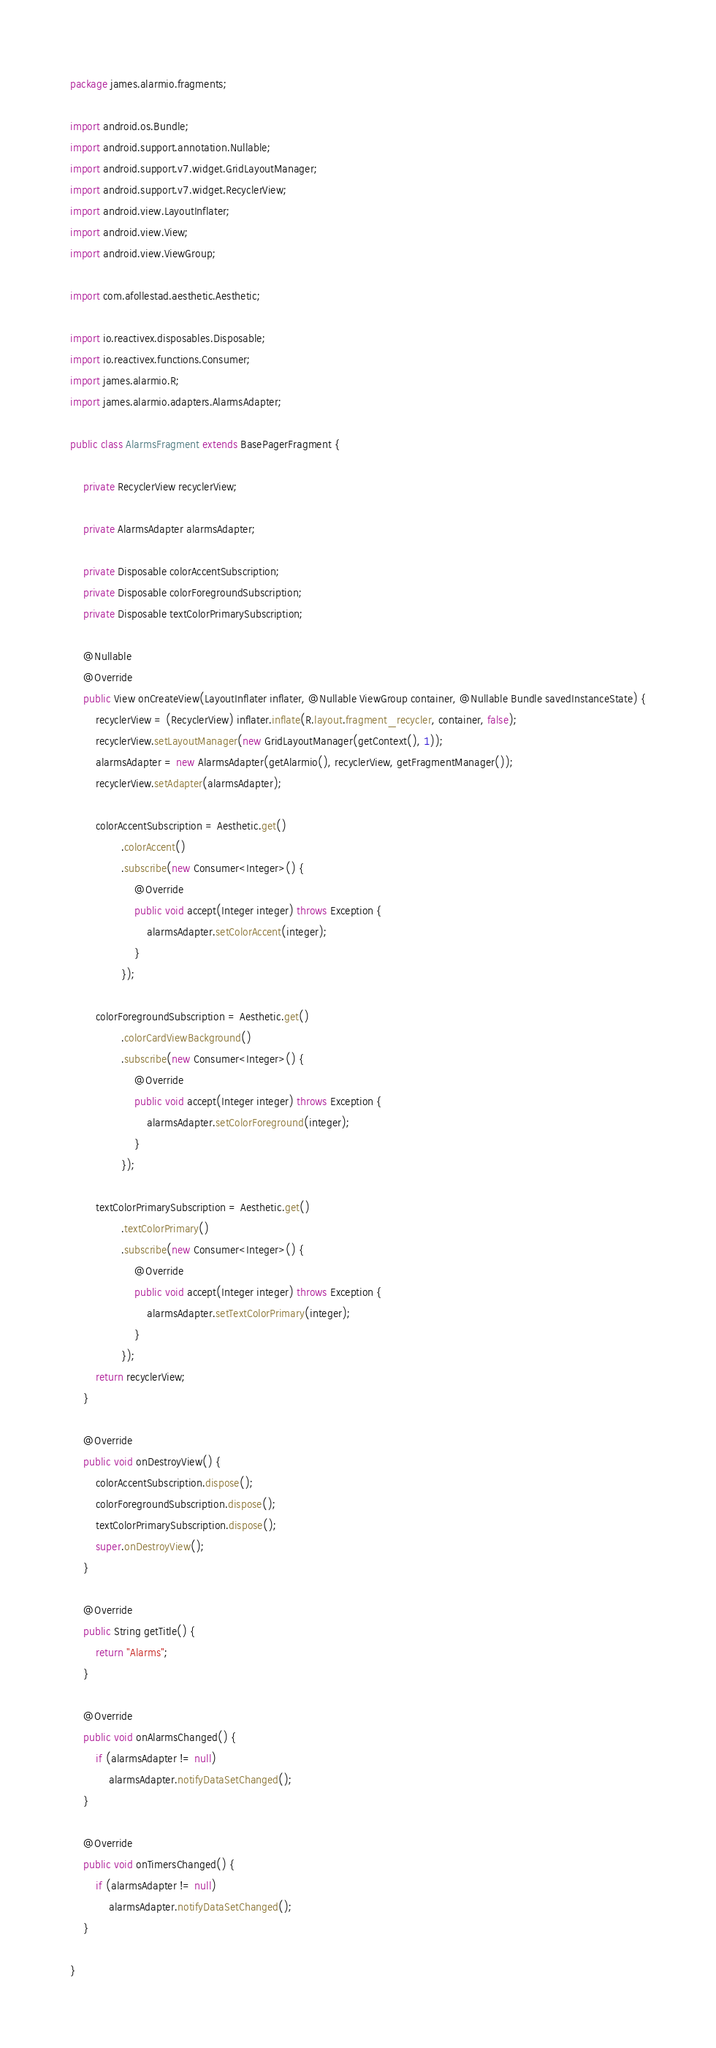Convert code to text. <code><loc_0><loc_0><loc_500><loc_500><_Java_>package james.alarmio.fragments;

import android.os.Bundle;
import android.support.annotation.Nullable;
import android.support.v7.widget.GridLayoutManager;
import android.support.v7.widget.RecyclerView;
import android.view.LayoutInflater;
import android.view.View;
import android.view.ViewGroup;

import com.afollestad.aesthetic.Aesthetic;

import io.reactivex.disposables.Disposable;
import io.reactivex.functions.Consumer;
import james.alarmio.R;
import james.alarmio.adapters.AlarmsAdapter;

public class AlarmsFragment extends BasePagerFragment {

    private RecyclerView recyclerView;

    private AlarmsAdapter alarmsAdapter;

    private Disposable colorAccentSubscription;
    private Disposable colorForegroundSubscription;
    private Disposable textColorPrimarySubscription;

    @Nullable
    @Override
    public View onCreateView(LayoutInflater inflater, @Nullable ViewGroup container, @Nullable Bundle savedInstanceState) {
        recyclerView = (RecyclerView) inflater.inflate(R.layout.fragment_recycler, container, false);
        recyclerView.setLayoutManager(new GridLayoutManager(getContext(), 1));
        alarmsAdapter = new AlarmsAdapter(getAlarmio(), recyclerView, getFragmentManager());
        recyclerView.setAdapter(alarmsAdapter);

        colorAccentSubscription = Aesthetic.get()
                .colorAccent()
                .subscribe(new Consumer<Integer>() {
                    @Override
                    public void accept(Integer integer) throws Exception {
                        alarmsAdapter.setColorAccent(integer);
                    }
                });

        colorForegroundSubscription = Aesthetic.get()
                .colorCardViewBackground()
                .subscribe(new Consumer<Integer>() {
                    @Override
                    public void accept(Integer integer) throws Exception {
                        alarmsAdapter.setColorForeground(integer);
                    }
                });

        textColorPrimarySubscription = Aesthetic.get()
                .textColorPrimary()
                .subscribe(new Consumer<Integer>() {
                    @Override
                    public void accept(Integer integer) throws Exception {
                        alarmsAdapter.setTextColorPrimary(integer);
                    }
                });
        return recyclerView;
    }

    @Override
    public void onDestroyView() {
        colorAccentSubscription.dispose();
        colorForegroundSubscription.dispose();
        textColorPrimarySubscription.dispose();
        super.onDestroyView();
    }

    @Override
    public String getTitle() {
        return "Alarms";
    }

    @Override
    public void onAlarmsChanged() {
        if (alarmsAdapter != null)
            alarmsAdapter.notifyDataSetChanged();
    }

    @Override
    public void onTimersChanged() {
        if (alarmsAdapter != null)
            alarmsAdapter.notifyDataSetChanged();
    }

}
</code> 